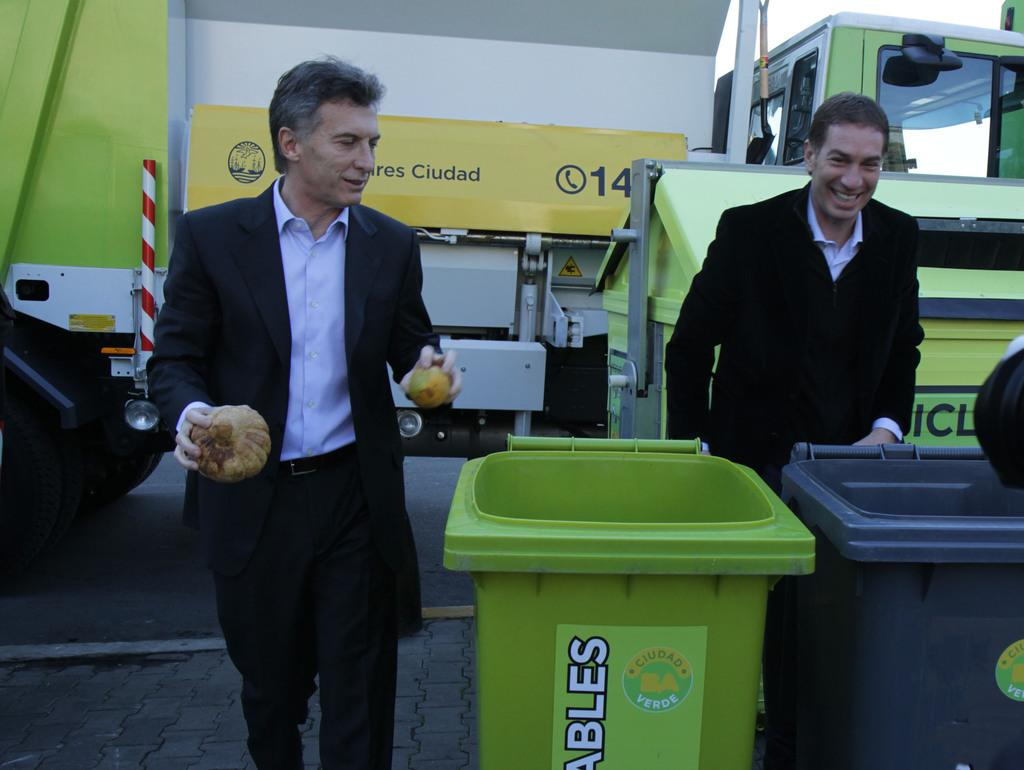Provide a one-sentence caption for the provided image. Two men are seen in front of a yellow awning, which has the number 14 on it. 